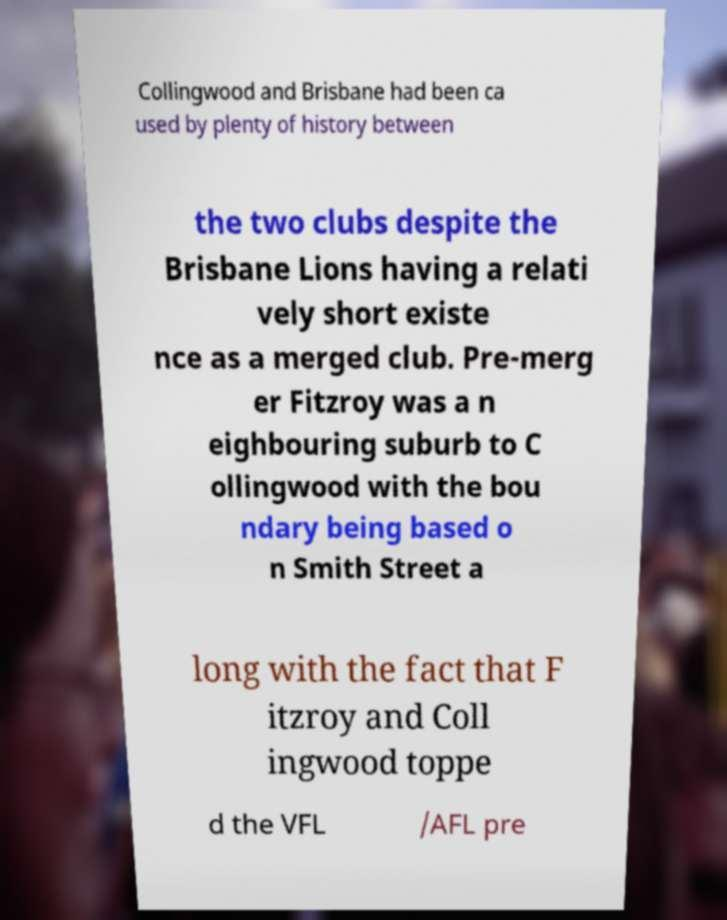There's text embedded in this image that I need extracted. Can you transcribe it verbatim? Collingwood and Brisbane had been ca used by plenty of history between the two clubs despite the Brisbane Lions having a relati vely short existe nce as a merged club. Pre-merg er Fitzroy was a n eighbouring suburb to C ollingwood with the bou ndary being based o n Smith Street a long with the fact that F itzroy and Coll ingwood toppe d the VFL /AFL pre 